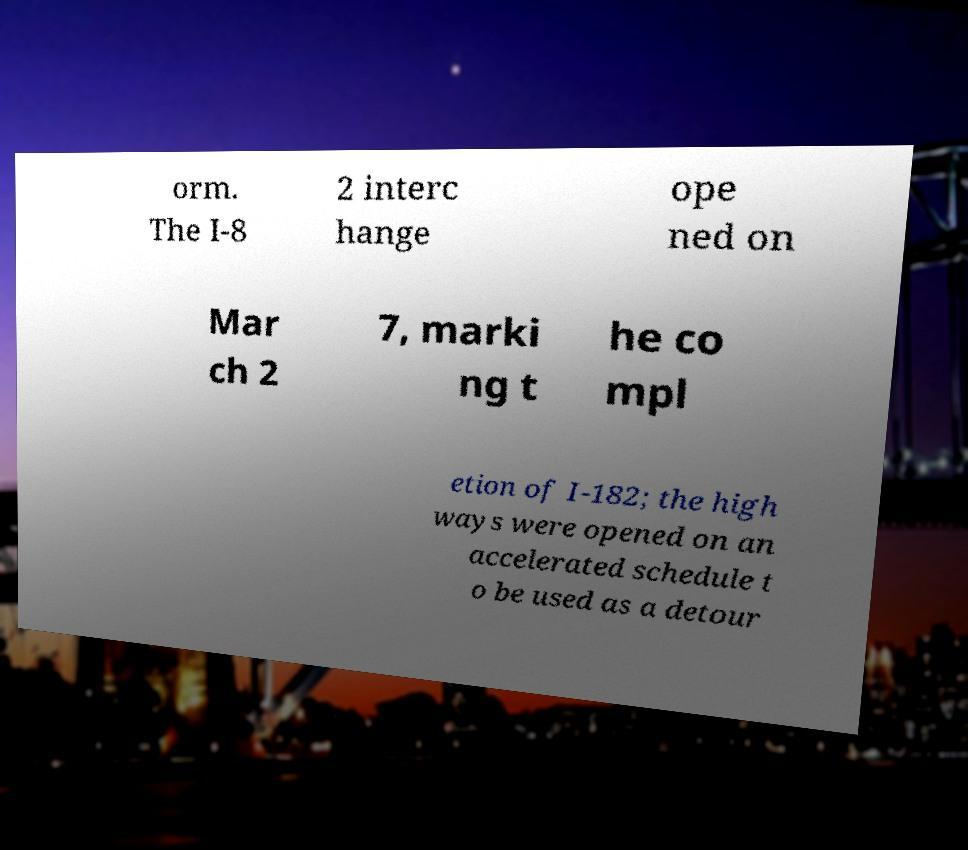Could you assist in decoding the text presented in this image and type it out clearly? orm. The I-8 2 interc hange ope ned on Mar ch 2 7, marki ng t he co mpl etion of I-182; the high ways were opened on an accelerated schedule t o be used as a detour 